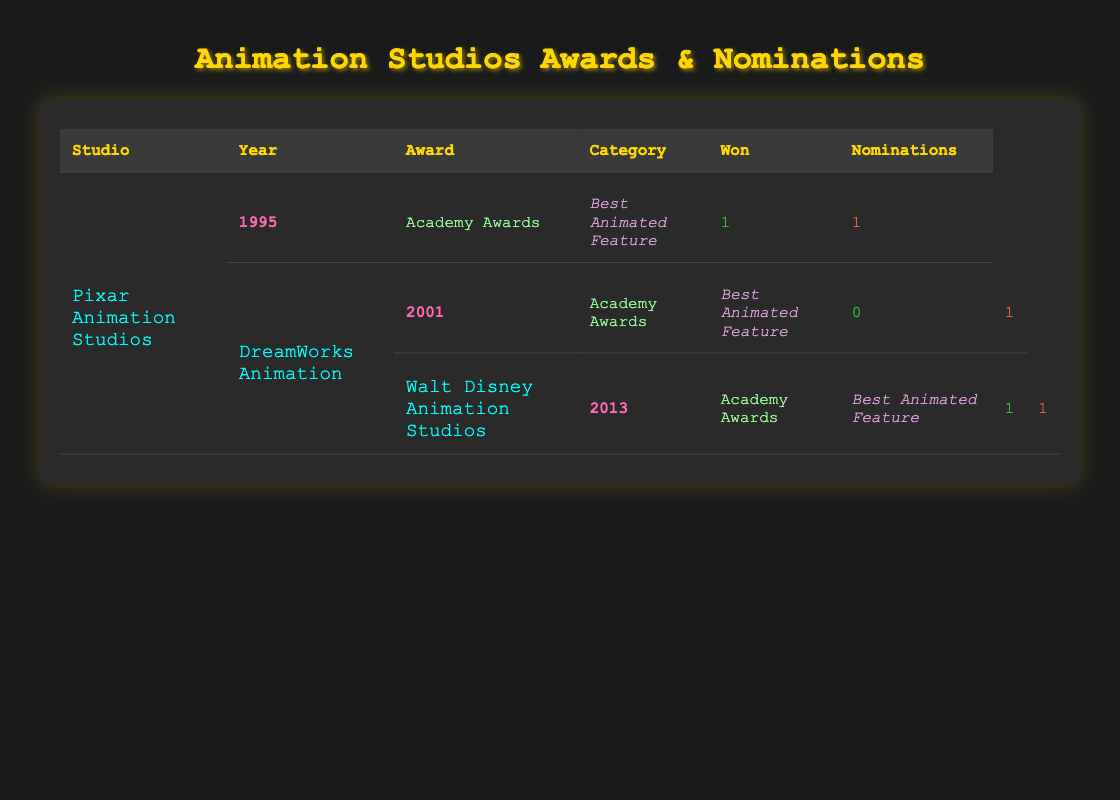What year did Pixar Animation Studios win its first Academy Award? According to the table, Pixar Animation Studios won its first Academy Award in the year 1995 for Best Animated Feature.
Answer: 1995 How many total awards did Walt Disney Animation Studios win in 2013? The table shows that Walt Disney Animation Studios won 1 Academy Award for Best Animated Feature in 2013. Therefore, the total awards won that year is 1.
Answer: 1 Did DreamWorks Animation win any Academy Awards in 2001? From the table, it is mentioned that DreamWorks Animation did not win any Academy Awards in 2001, as the row indicates they had 0 wins despite having 1 nomination.
Answer: No How many nominations did Pixar Animation Studios receive in total across the years displayed? By adding the nominations from both years shown for Pixar Animation Studios: 1 nomination for 1995 and 2 nominations for 2016 (1 + 2 = 3). Thus, the total nominations are 3.
Answer: 3 Which studio had the most nominations in a single year based on the table? Analyzing the table, DreamWorks Animation had 2 nominations in 2019, as did Pixar Animation Studios in 2016. However, Walt Disney Animation Studios had only 1 nomination across its years. Therefore, the answer is that both DreamWorks Animation in 2019 and Pixar Animation Studios in 2016 had the most nominations in a single year with 2 nominations.
Answer: DreamWorks Animation and Pixar Animation Studios In what year did both Pixar Animation Studios and Walt Disney Animation Studios win an Academy Award? The table shows that Pixar Animation Studios won an Academy Award in 1995 and 2016, while Walt Disney Animation Studios won it in 2013. Therefore, no year has both studios winning an Academy Award according to the displayed data.
Answer: None What percentage of nominations did DreamWorks Animation convert into wins in 2019? In 2019, DreamWorks Animation had 2 nominations (from the Annie Awards) and won 1 award. To find the percentage, (1 win / 2 nominations) * 100 = 50%. Thus, DreamWorks Animation converted 50% of its nominations into wins in that year.
Answer: 50% What is the total number of awards won by all studios combined? By adding the total wins: Pixar Animation Studios won 2 (1 in 1995 and 1 in 2016), DreamWorks Animation won 1 in 2019, and Walt Disney Animation Studios won 1 in 2013. Therefore, the total is 2 + 1 + 1 = 4.
Answer: 4 